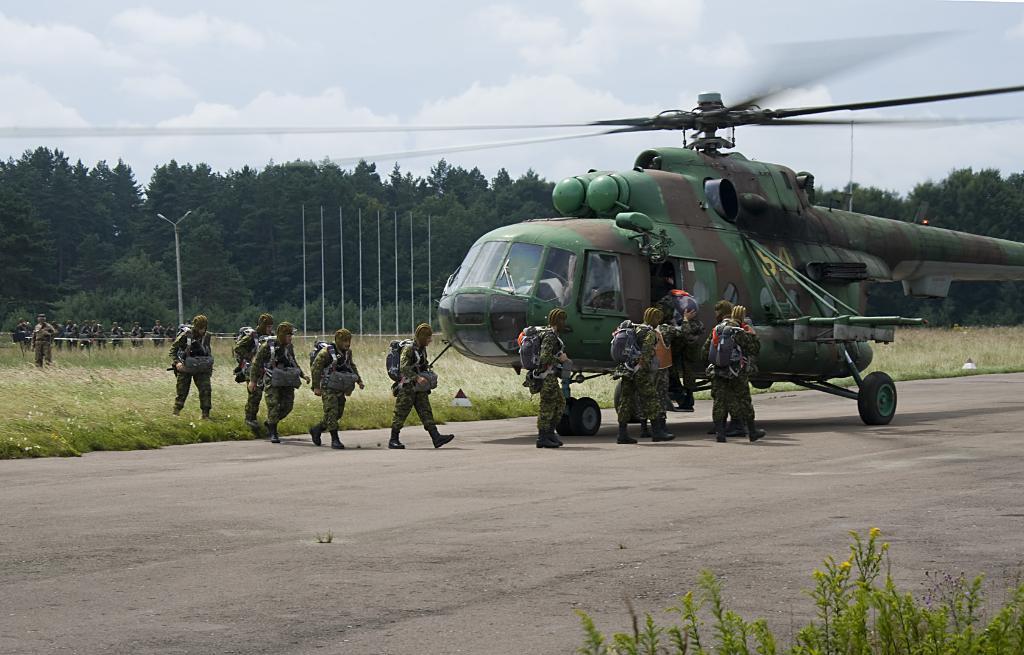In one or two sentences, can you explain what this image depicts? In this image there is a helicopter in the middle and in front of it there are few officers who are getting in to the helicopter. At the top there is sky. In the background there are trees. In front of trees there are poles. 